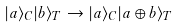Convert formula to latex. <formula><loc_0><loc_0><loc_500><loc_500>| a \rangle _ { C } | b \rangle _ { T } \rightarrow | a \rangle _ { C } | a \oplus b \rangle _ { T }</formula> 